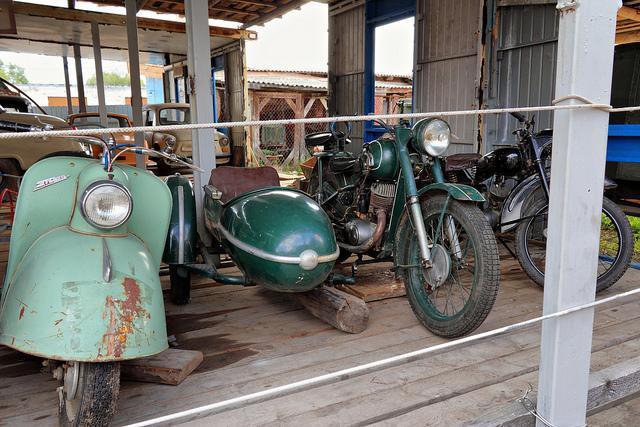How many cars are there?
Give a very brief answer. 2. How many motorcycles can you see?
Give a very brief answer. 3. How many trucks are there?
Give a very brief answer. 2. 